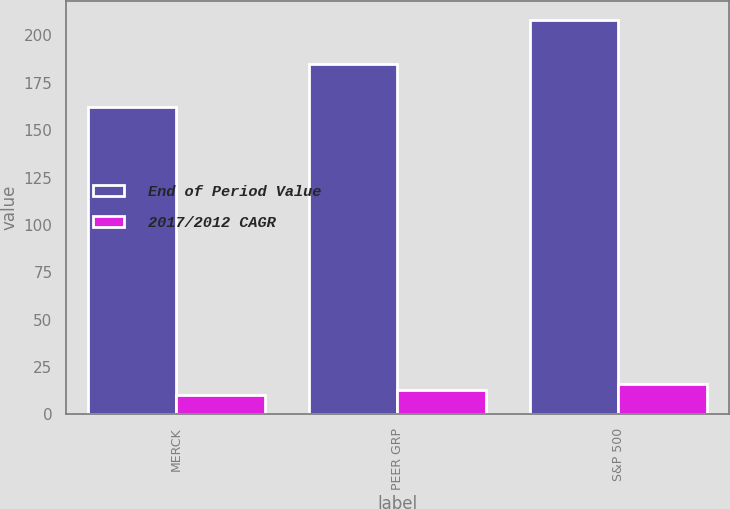Convert chart. <chart><loc_0><loc_0><loc_500><loc_500><stacked_bar_chart><ecel><fcel>MERCK<fcel>PEER GRP<fcel>S&P 500<nl><fcel>End of Period Value<fcel>162<fcel>185<fcel>208<nl><fcel>2017/2012 CAGR<fcel>10<fcel>13<fcel>16<nl></chart> 